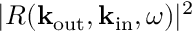Convert formula to latex. <formula><loc_0><loc_0><loc_500><loc_500>| R ( { k } _ { o u t } , { k } _ { i n } , \omega ) | ^ { 2 }</formula> 